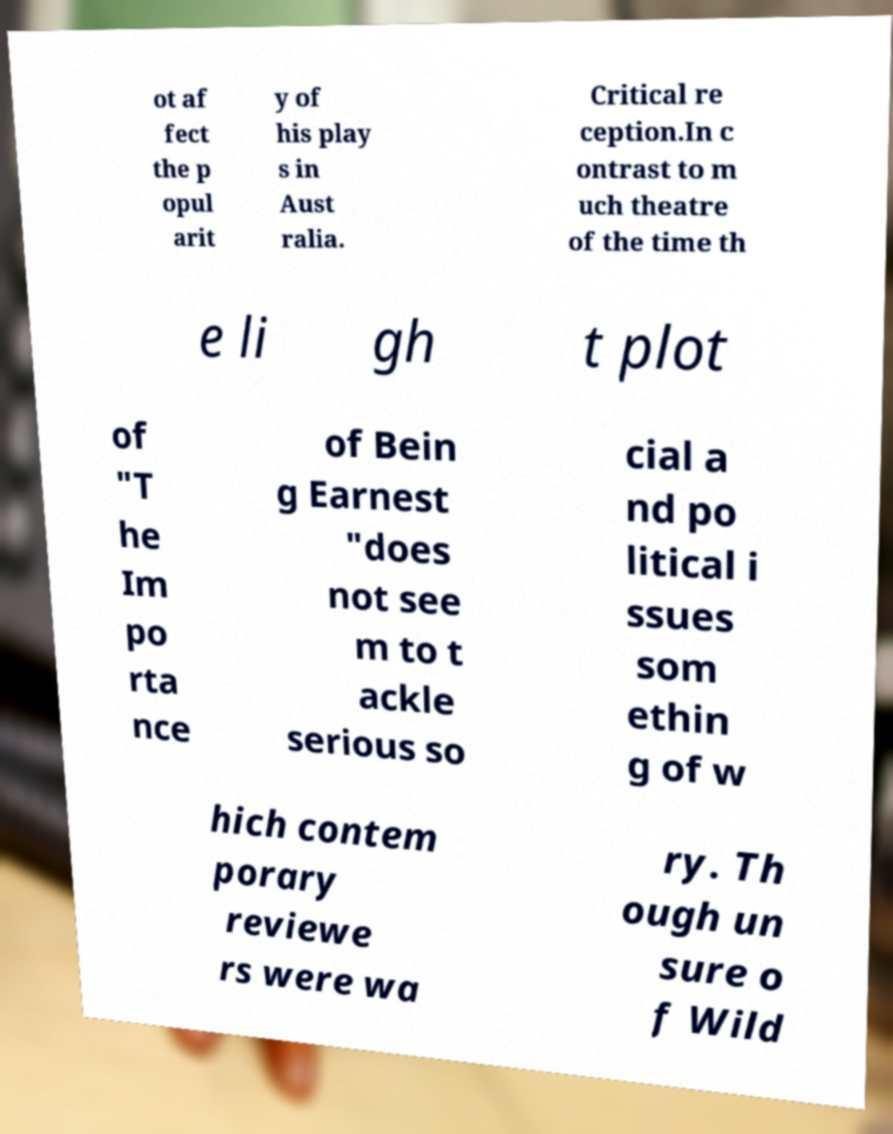What messages or text are displayed in this image? I need them in a readable, typed format. ot af fect the p opul arit y of his play s in Aust ralia. Critical re ception.In c ontrast to m uch theatre of the time th e li gh t plot of "T he Im po rta nce of Bein g Earnest "does not see m to t ackle serious so cial a nd po litical i ssues som ethin g of w hich contem porary reviewe rs were wa ry. Th ough un sure o f Wild 